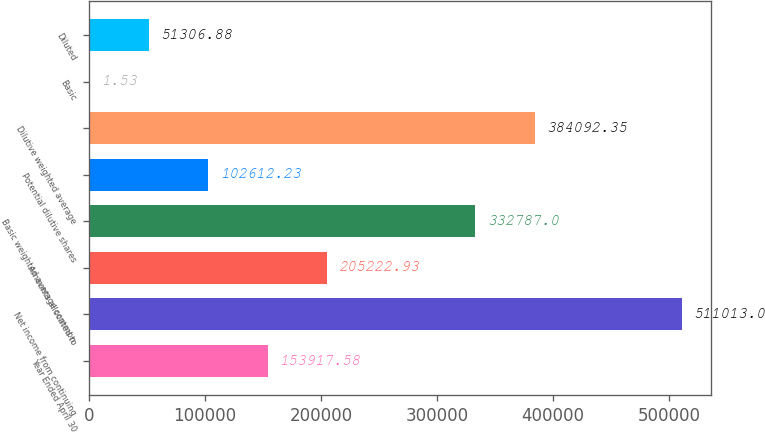Convert chart to OTSL. <chart><loc_0><loc_0><loc_500><loc_500><bar_chart><fcel>Year Ended April 30<fcel>Net income from continuing<fcel>Amounts allocated to<fcel>Basic weighted average common<fcel>Potential dilutive shares<fcel>Dilutive weighted average<fcel>Basic<fcel>Diluted<nl><fcel>153918<fcel>511013<fcel>205223<fcel>332787<fcel>102612<fcel>384092<fcel>1.53<fcel>51306.9<nl></chart> 